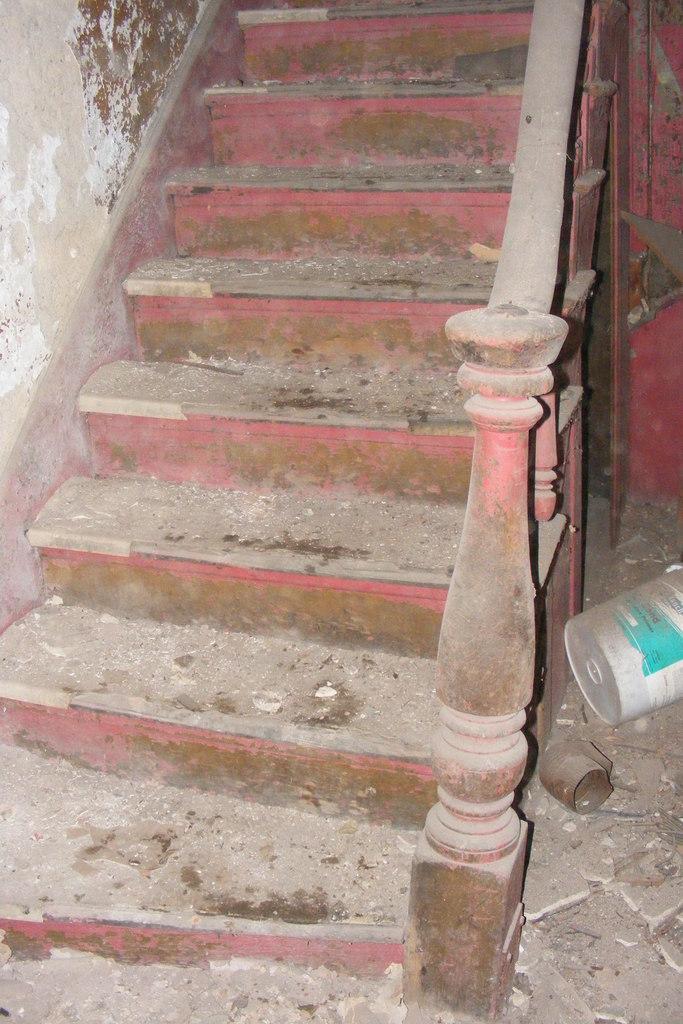In one or two sentences, can you explain what this image depicts? In this image there are staircase. There is a staircase railing. To the right side of the image there is a bucket. To the left side of the image there is a wall. 